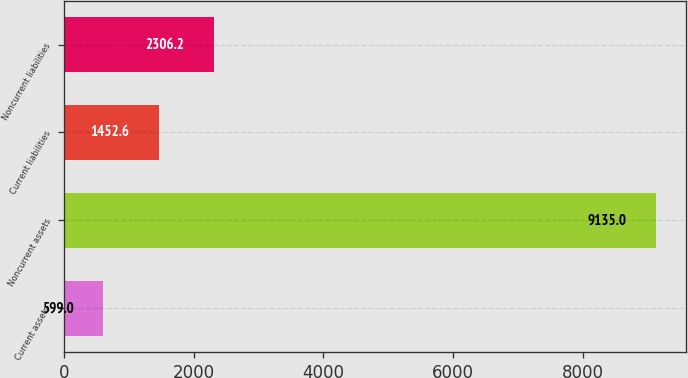<chart> <loc_0><loc_0><loc_500><loc_500><bar_chart><fcel>Current assets<fcel>Noncurrent assets<fcel>Current liabilities<fcel>Noncurrent liabilities<nl><fcel>599<fcel>9135<fcel>1452.6<fcel>2306.2<nl></chart> 